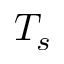<formula> <loc_0><loc_0><loc_500><loc_500>T _ { s }</formula> 